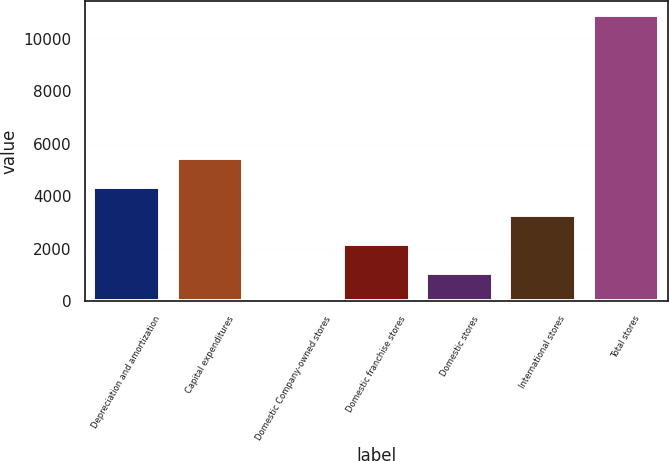<chart> <loc_0><loc_0><loc_500><loc_500><bar_chart><fcel>Depreciation and amortization<fcel>Capital expenditures<fcel>Domestic Company-owned stores<fcel>Domestic franchise stores<fcel>Domestic stores<fcel>International stores<fcel>Total stores<nl><fcel>4356.74<fcel>5444.95<fcel>3.9<fcel>2180.32<fcel>1092.11<fcel>3268.53<fcel>10886<nl></chart> 